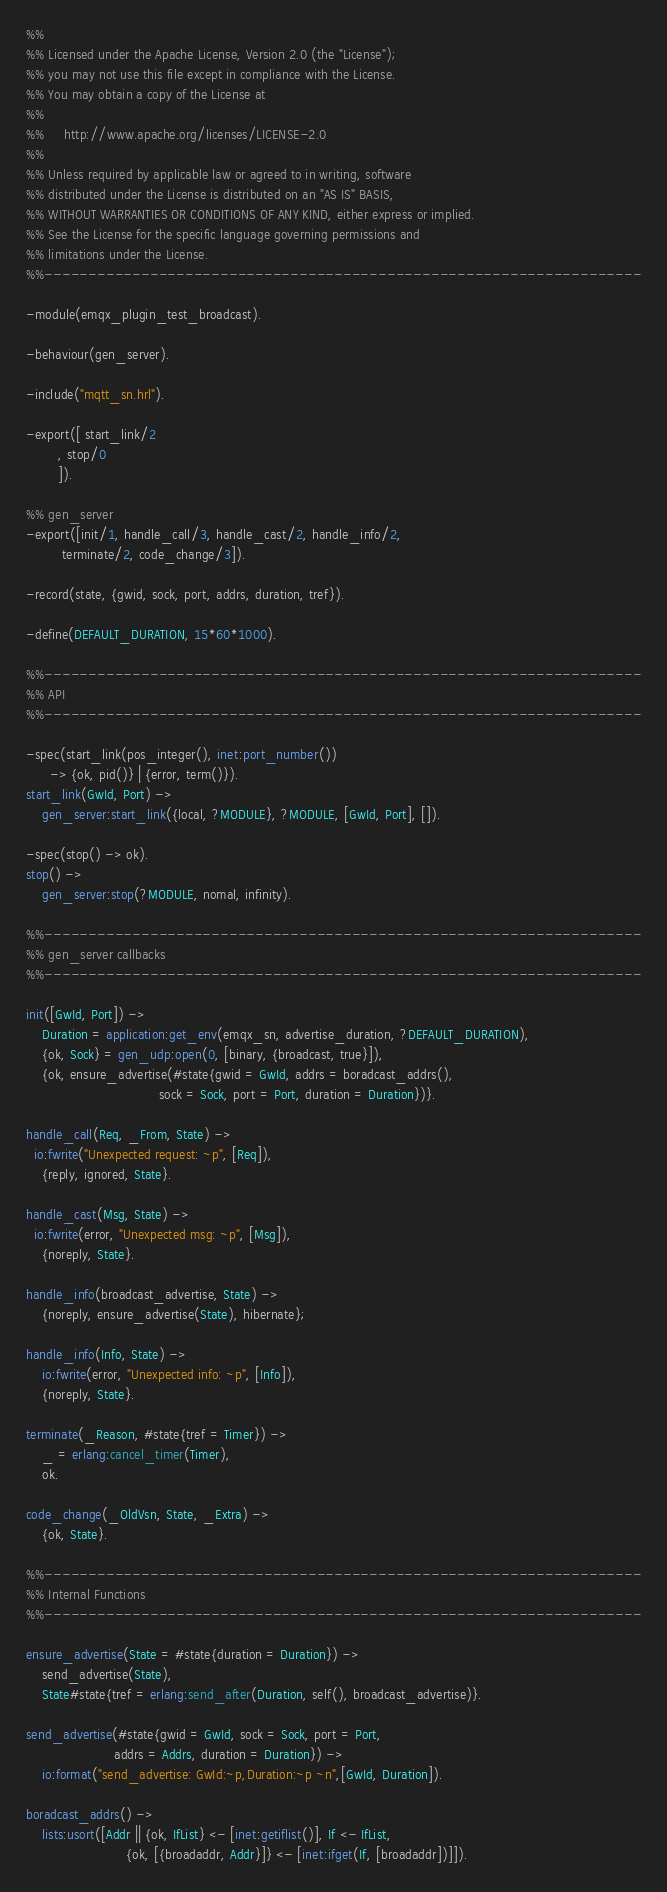Convert code to text. <code><loc_0><loc_0><loc_500><loc_500><_Erlang_>%%
%% Licensed under the Apache License, Version 2.0 (the "License");
%% you may not use this file except in compliance with the License.
%% You may obtain a copy of the License at
%%
%%     http://www.apache.org/licenses/LICENSE-2.0
%%
%% Unless required by applicable law or agreed to in writing, software
%% distributed under the License is distributed on an "AS IS" BASIS,
%% WITHOUT WARRANTIES OR CONDITIONS OF ANY KIND, either express or implied.
%% See the License for the specific language governing permissions and
%% limitations under the License.
%%--------------------------------------------------------------------

-module(emqx_plugin_test_broadcast).

-behaviour(gen_server).

-include("mqtt_sn.hrl").

-export([ start_link/2
        , stop/0
        ]).

%% gen_server
-export([init/1, handle_call/3, handle_cast/2, handle_info/2,
         terminate/2, code_change/3]).

-record(state, {gwid, sock, port, addrs, duration, tref}).

-define(DEFAULT_DURATION, 15*60*1000).

%%--------------------------------------------------------------------
%% API
%%--------------------------------------------------------------------

-spec(start_link(pos_integer(), inet:port_number())
      -> {ok, pid()} | {error, term()}).
start_link(GwId, Port) ->
	gen_server:start_link({local, ?MODULE}, ?MODULE, [GwId, Port], []).

-spec(stop() -> ok).
stop() ->
    gen_server:stop(?MODULE, nomal, infinity).

%%--------------------------------------------------------------------
%% gen_server callbacks
%%--------------------------------------------------------------------

init([GwId, Port]) ->
    Duration = application:get_env(emqx_sn, advertise_duration, ?DEFAULT_DURATION),
    {ok, Sock} = gen_udp:open(0, [binary, {broadcast, true}]),
    {ok, ensure_advertise(#state{gwid = GwId, addrs = boradcast_addrs(),
                                 sock = Sock, port = Port, duration = Duration})}.

handle_call(Req, _From, State) ->
  io:fwrite("Unexpected request: ~p", [Req]),
	{reply, ignored, State}.

handle_cast(Msg, State) ->
  io:fwrite(error, "Unexpected msg: ~p", [Msg]),
	{noreply, State}.

handle_info(broadcast_advertise, State) ->
    {noreply, ensure_advertise(State), hibernate};

handle_info(Info, State) ->
    io:fwrite(error, "Unexpected info: ~p", [Info]),
	{noreply, State}.

terminate(_Reason, #state{tref = Timer}) ->
    _ = erlang:cancel_timer(Timer),
    ok.

code_change(_OldVsn, State, _Extra) ->
	{ok, State}.

%%--------------------------------------------------------------------
%% Internal Functions
%%--------------------------------------------------------------------

ensure_advertise(State = #state{duration = Duration}) ->
    send_advertise(State),
    State#state{tref = erlang:send_after(Duration, self(), broadcast_advertise)}.

send_advertise(#state{gwid = GwId, sock = Sock, port = Port,
                      addrs = Addrs, duration = Duration}) ->
    io:format("send_advertise: GwId:~p,Duration:~p ~n",[GwId, Duration]).

boradcast_addrs() ->
    lists:usort([Addr || {ok, IfList} <- [inet:getiflist()], If <- IfList,
                         {ok, [{broadaddr, Addr}]} <- [inet:ifget(If, [broadaddr])]]).

</code> 